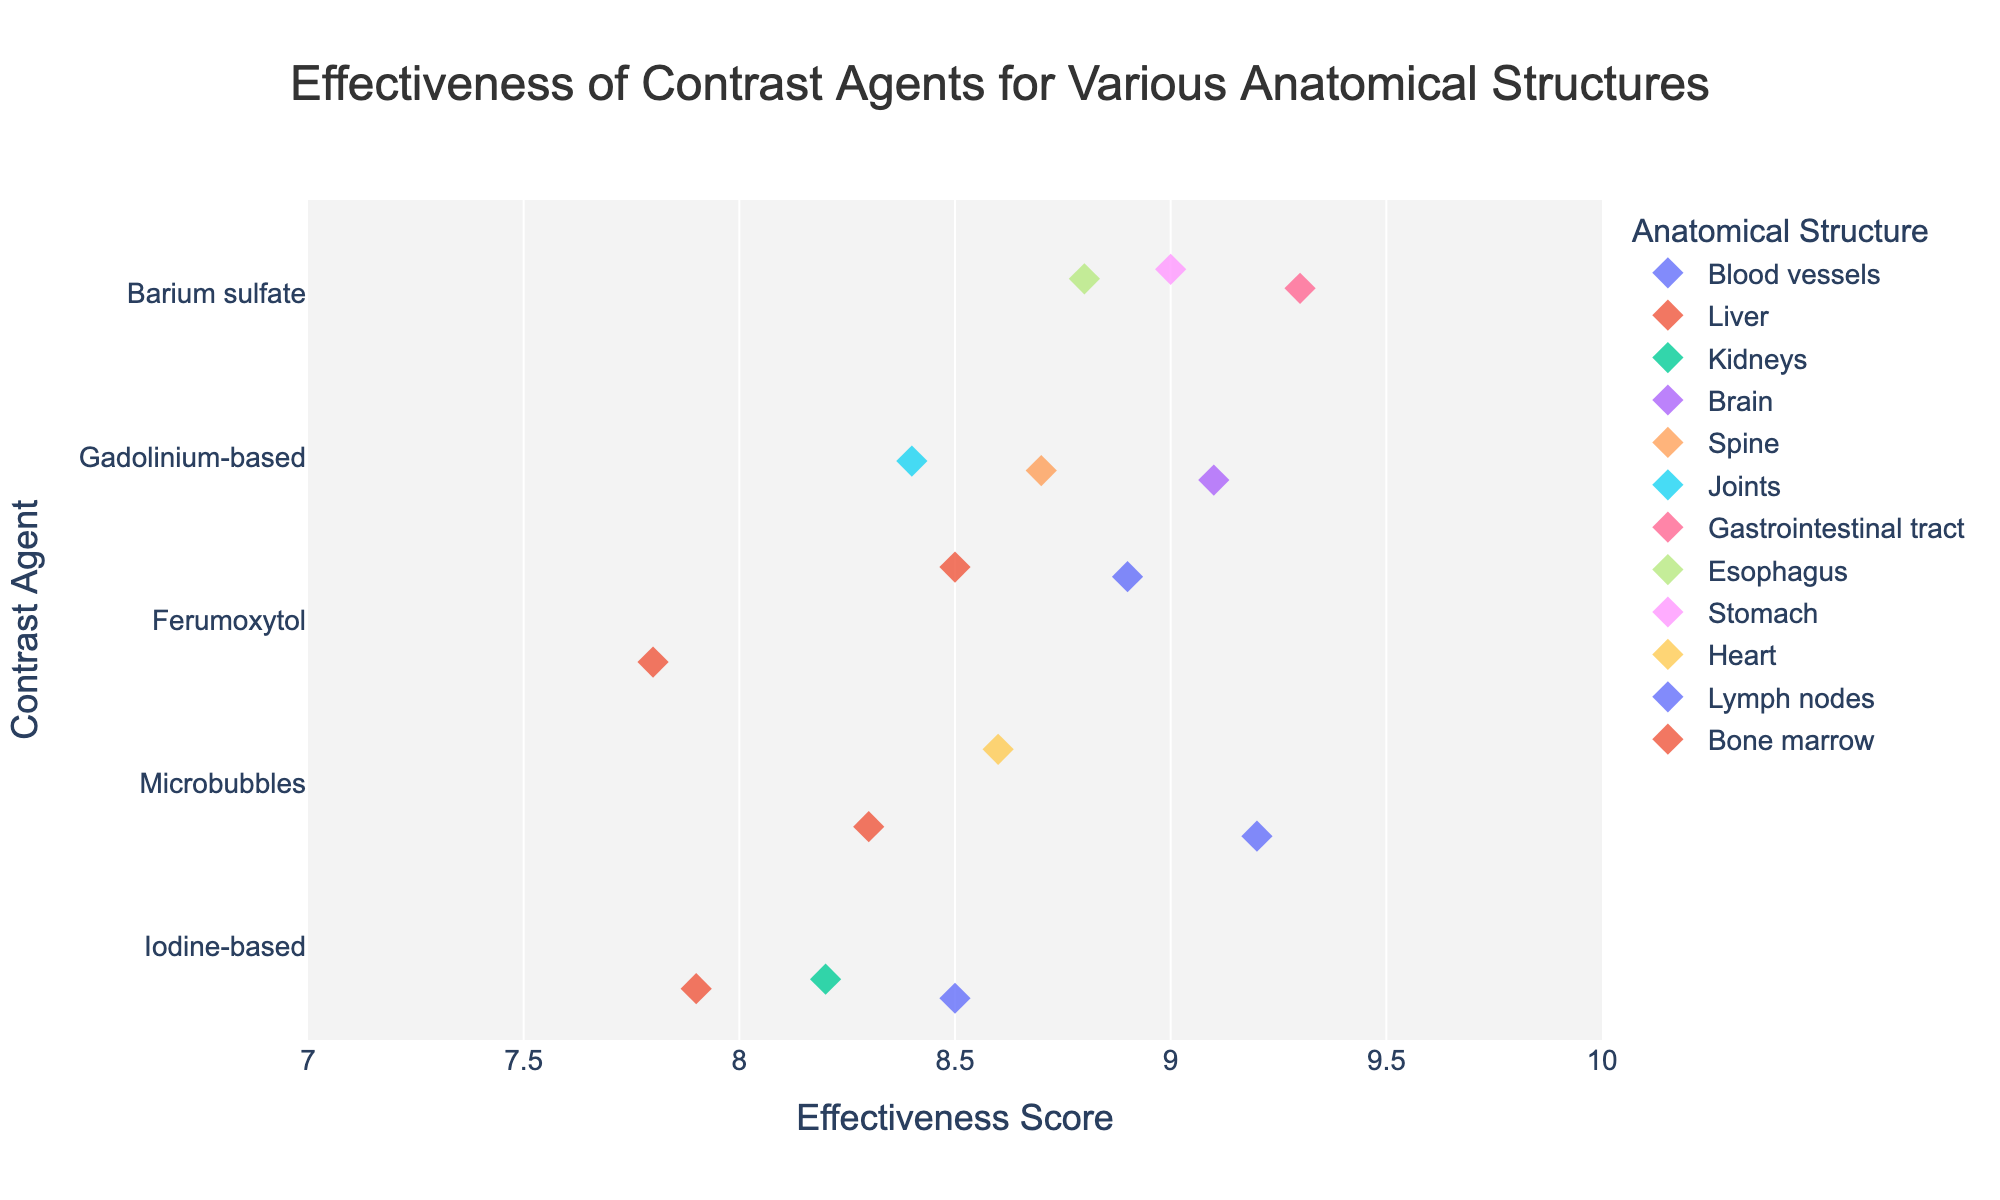What is the title of the plot? The title of the plot is displayed at the top of the figure.
Answer: Effectiveness of Contrast Agents for Various Anatomical Structures What does the x-axis represent? The x-axis represents the effectiveness score, which measures how effective each contrast agent is for enhancing image quality of the anatomical structures.
Answer: Effectiveness Score Which contrast agent has the highest effectiveness score for any anatomical structure? By looking at the highest point on the x-axis, we observe that the Barium sulfate for the Gastrointestinal tract has the highest score.
Answer: Barium sulfate for the Gastrointestinal tract How many anatomical structures are represented for Gadolinium-based contrast agent? By observing the color legend and counting the distinct anatomical structures associated with Gadolinium-based contrast agent, we find three structures: Brain, Spine, and Joints.
Answer: 3 Compare the effectiveness scores of Iodine-based and Ferumoxytol for the Liver. Which one is higher? Observing the plot, we see the Iodine-based score is slightly higher than the corresponding Ferumoxytol score for the Liver.
Answer: Iodine-based What is the range of effectiveness scores shown on the x-axis? The x-axis shows effectiveness scores ranging from 7 to 10, as indicated by the tick marks and axis labels.
Answer: 7 to 10 Which anatomical structure associated with Microbubbles has the highest effectiveness score? By looking at the different points for Microbubbles and comparing their positions on the x-axis, it is evident that the Blood vessels have the highest score.
Answer: Blood vessels What is the average effectiveness score of the Gadolinium-based contrast agent across all its associated anatomical structures? Adding the effectiveness scores for Brain (9.1), Spine (8.7), and Joints (8.4), then dividing by the number of structures (3) gives the average: (9.1 + 8.7 + 8.4) / 3 = 8.73.
Answer: 8.73 Are there any anatomical structures that have effectiveness scores below 8? By observing all the points on the plot, none of the effectiveness scores fall below 8, as all data points are between 7.8 and 9.3 on the x-axis.
Answer: No What color represents the anatomical structure “Heart”? Referring to the color legend in the plot, we can identify the color associated with "Heart".
Answer: Microbubbles 